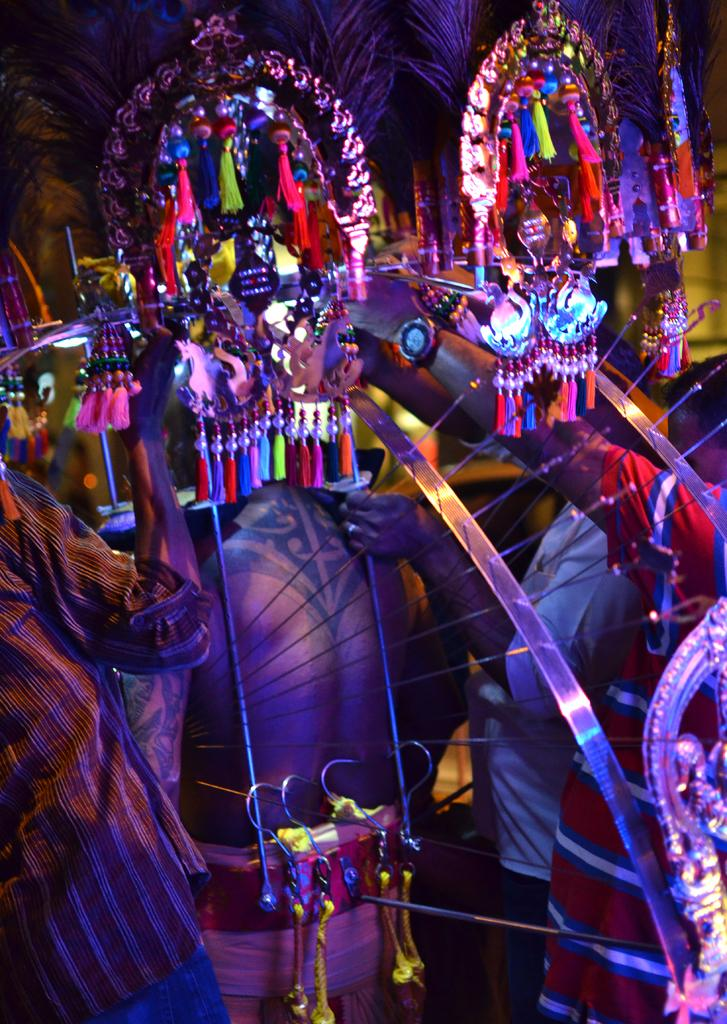How many people are in the image? There is a group of people in the image. What are the people wearing? The people are wearing different costumes. What time is the meeting scheduled for in the image? There is no meeting or specific time mentioned in the image; it only shows a group of people wearing different costumes. 